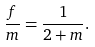Convert formula to latex. <formula><loc_0><loc_0><loc_500><loc_500>\frac { f } { m } = \frac { 1 } { 2 + m } .</formula> 